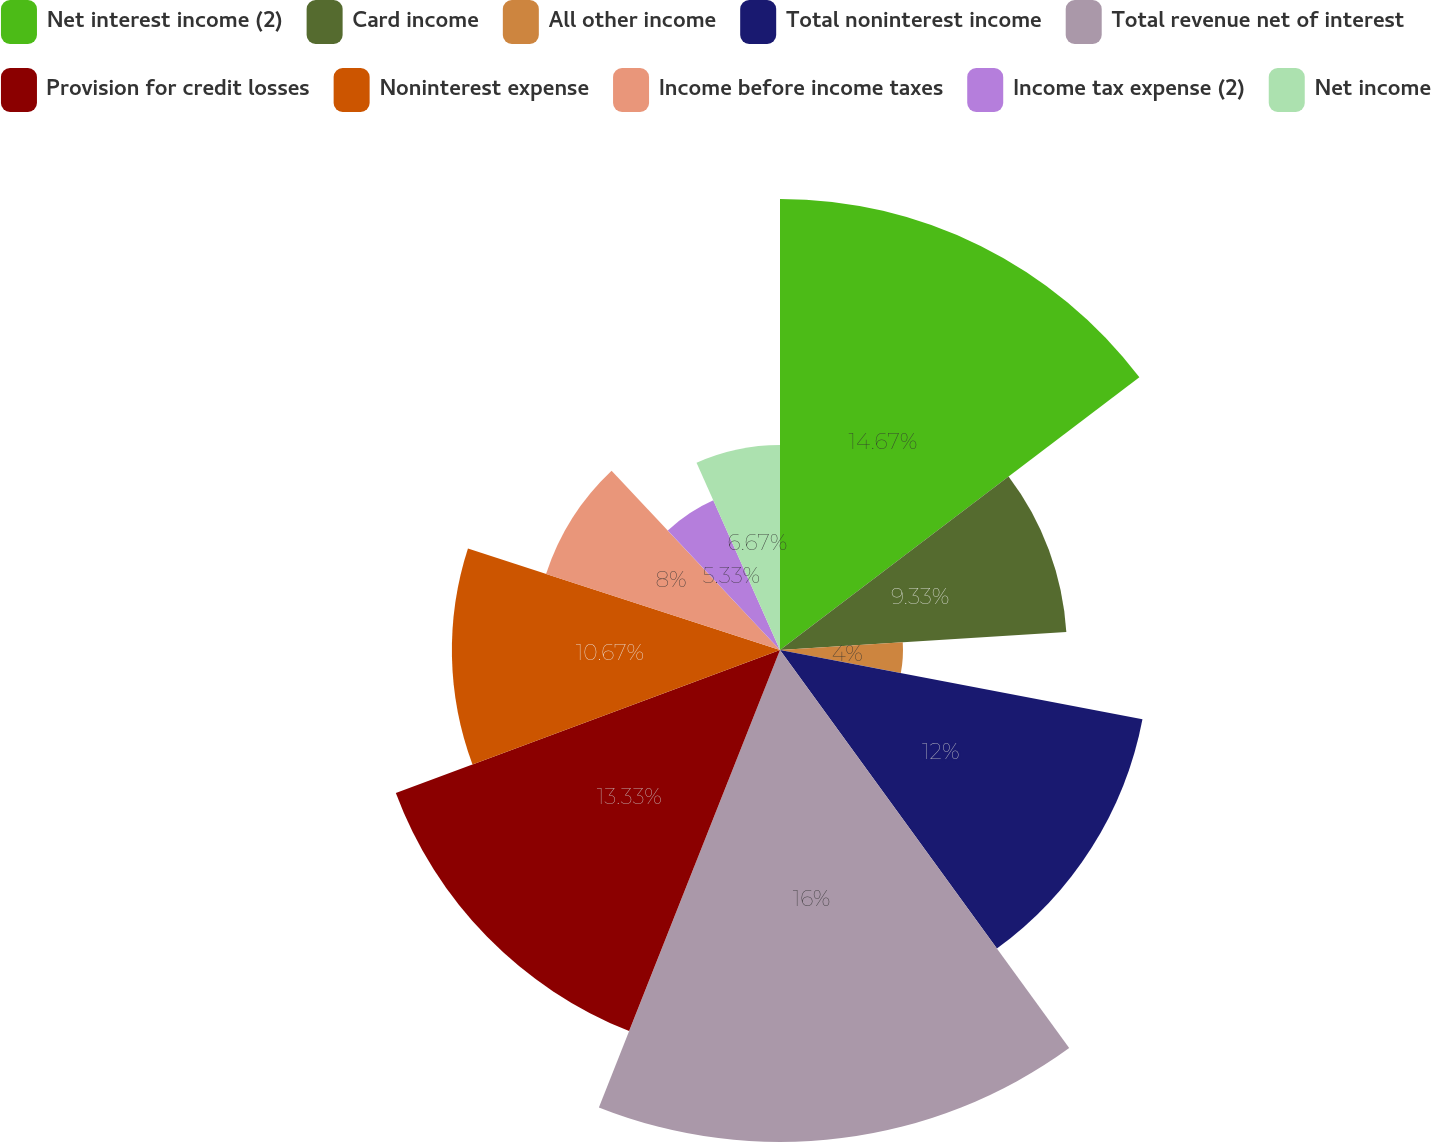Convert chart. <chart><loc_0><loc_0><loc_500><loc_500><pie_chart><fcel>Net interest income (2)<fcel>Card income<fcel>All other income<fcel>Total noninterest income<fcel>Total revenue net of interest<fcel>Provision for credit losses<fcel>Noninterest expense<fcel>Income before income taxes<fcel>Income tax expense (2)<fcel>Net income<nl><fcel>14.67%<fcel>9.33%<fcel>4.0%<fcel>12.0%<fcel>16.0%<fcel>13.33%<fcel>10.67%<fcel>8.0%<fcel>5.33%<fcel>6.67%<nl></chart> 